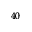<formula> <loc_0><loc_0><loc_500><loc_500>^ { 4 0 }</formula> 